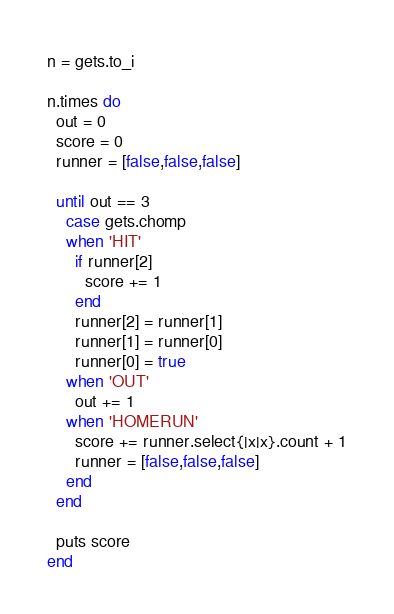Convert code to text. <code><loc_0><loc_0><loc_500><loc_500><_Ruby_>n = gets.to_i

n.times do
  out = 0
  score = 0
  runner = [false,false,false]

  until out == 3
    case gets.chomp
    when 'HIT'
      if runner[2]
        score += 1
      end
      runner[2] = runner[1]
      runner[1] = runner[0]
      runner[0] = true
    when 'OUT'
      out += 1
    when 'HOMERUN'
      score += runner.select{|x|x}.count + 1
      runner = [false,false,false]
    end
  end

  puts score
end</code> 